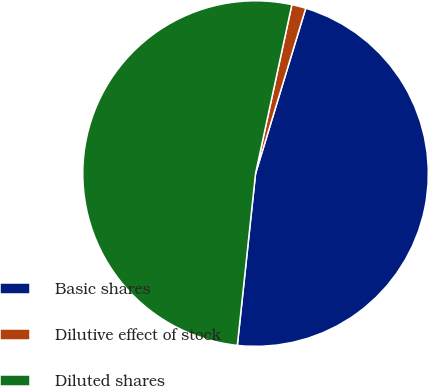<chart> <loc_0><loc_0><loc_500><loc_500><pie_chart><fcel>Basic shares<fcel>Dilutive effect of stock<fcel>Diluted shares<nl><fcel>46.99%<fcel>1.32%<fcel>51.69%<nl></chart> 